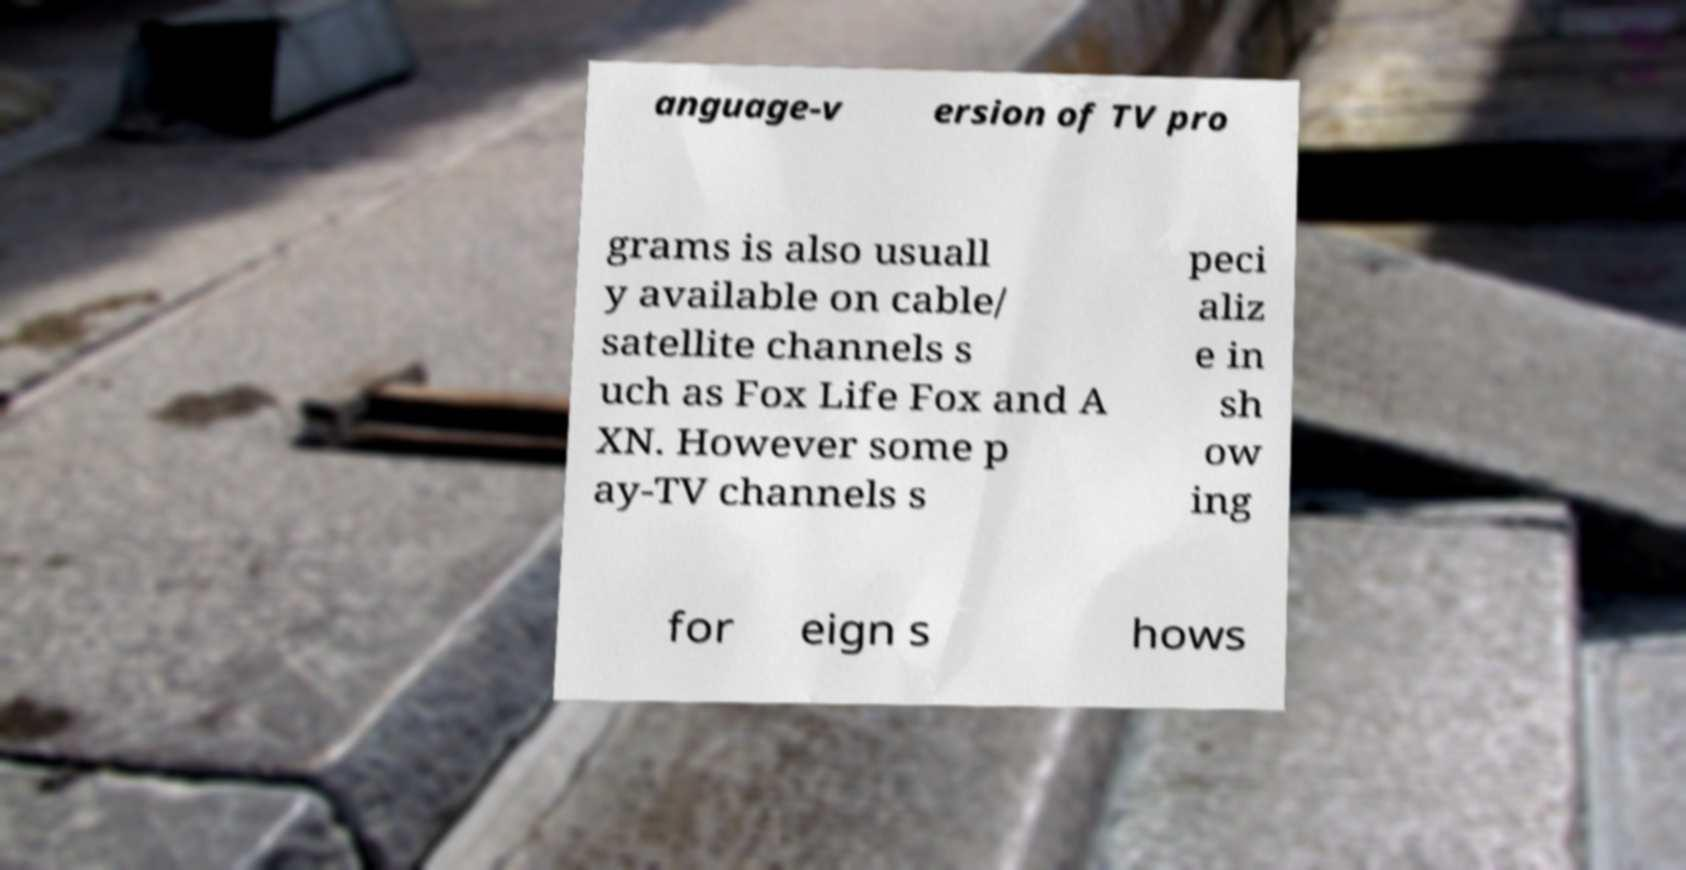Could you extract and type out the text from this image? anguage-v ersion of TV pro grams is also usuall y available on cable/ satellite channels s uch as Fox Life Fox and A XN. However some p ay-TV channels s peci aliz e in sh ow ing for eign s hows 